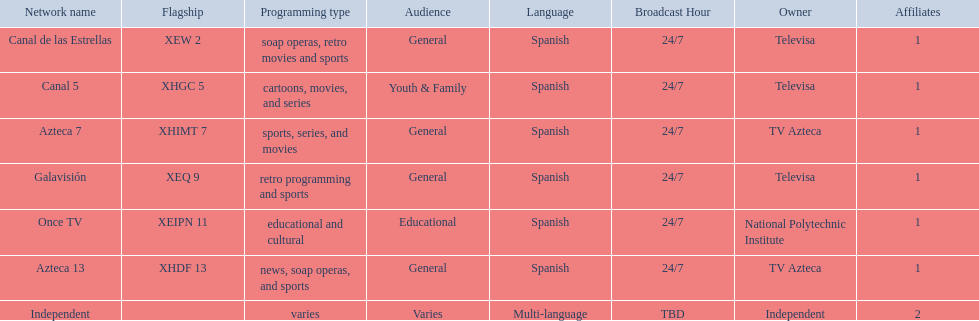What is the difference between the number of affiliates galavision has and the number of affiliates azteca 13 has? 0. 